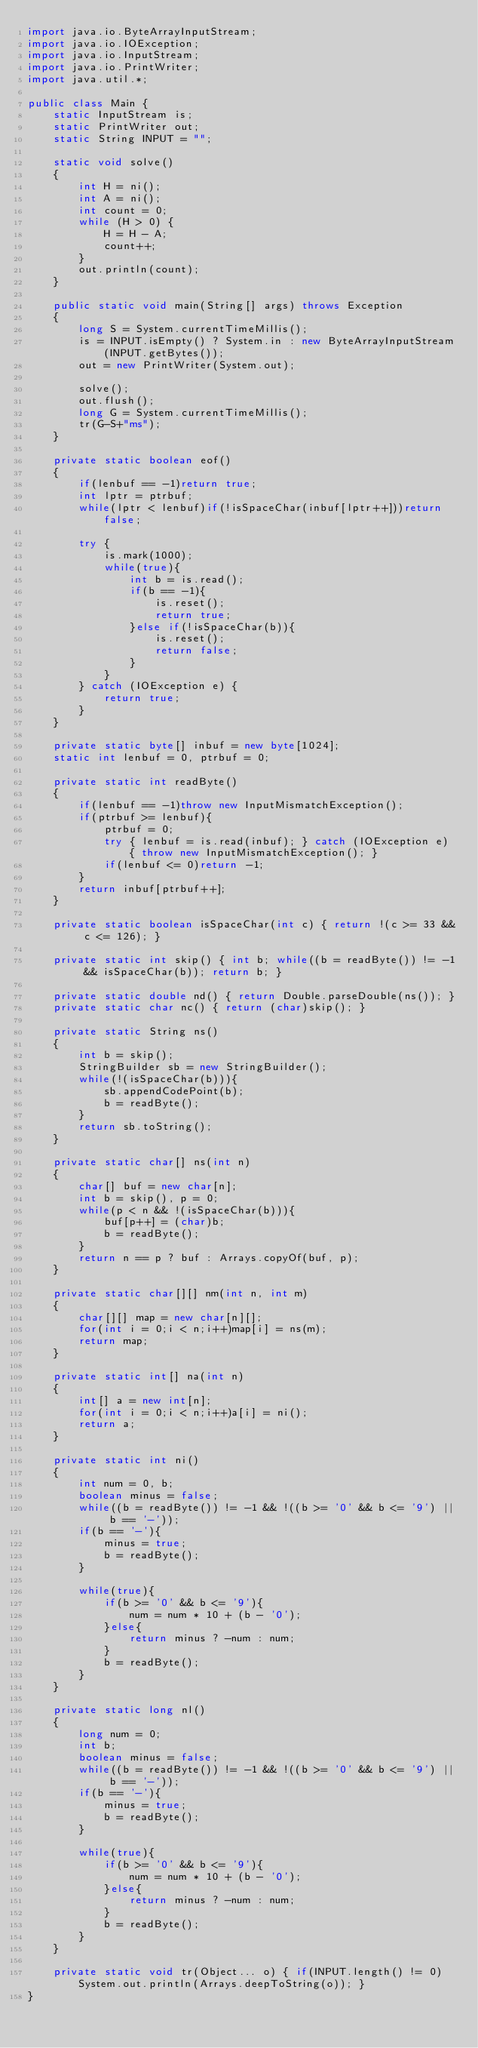Convert code to text. <code><loc_0><loc_0><loc_500><loc_500><_Java_>import java.io.ByteArrayInputStream;
import java.io.IOException;
import java.io.InputStream;
import java.io.PrintWriter;
import java.util.*;

public class Main {
    static InputStream is;
    static PrintWriter out;
    static String INPUT = "";

    static void solve()
    {
        int H = ni();
        int A = ni();
        int count = 0;
        while (H > 0) {
            H = H - A;
            count++;
        }
        out.println(count);
    }

    public static void main(String[] args) throws Exception
    {
        long S = System.currentTimeMillis();
        is = INPUT.isEmpty() ? System.in : new ByteArrayInputStream(INPUT.getBytes());
        out = new PrintWriter(System.out);

        solve();
        out.flush();
        long G = System.currentTimeMillis();
        tr(G-S+"ms");
    }

    private static boolean eof()
    {
        if(lenbuf == -1)return true;
        int lptr = ptrbuf;
        while(lptr < lenbuf)if(!isSpaceChar(inbuf[lptr++]))return false;

        try {
            is.mark(1000);
            while(true){
                int b = is.read();
                if(b == -1){
                    is.reset();
                    return true;
                }else if(!isSpaceChar(b)){
                    is.reset();
                    return false;
                }
            }
        } catch (IOException e) {
            return true;
        }
    }

    private static byte[] inbuf = new byte[1024];
    static int lenbuf = 0, ptrbuf = 0;

    private static int readByte()
    {
        if(lenbuf == -1)throw new InputMismatchException();
        if(ptrbuf >= lenbuf){
            ptrbuf = 0;
            try { lenbuf = is.read(inbuf); } catch (IOException e) { throw new InputMismatchException(); }
            if(lenbuf <= 0)return -1;
        }
        return inbuf[ptrbuf++];
    }

    private static boolean isSpaceChar(int c) { return !(c >= 33 && c <= 126); }

    private static int skip() { int b; while((b = readByte()) != -1 && isSpaceChar(b)); return b; }

    private static double nd() { return Double.parseDouble(ns()); }
    private static char nc() { return (char)skip(); }

    private static String ns()
    {
        int b = skip();
        StringBuilder sb = new StringBuilder();
        while(!(isSpaceChar(b))){
            sb.appendCodePoint(b);
            b = readByte();
        }
        return sb.toString();
    }

    private static char[] ns(int n)
    {
        char[] buf = new char[n];
        int b = skip(), p = 0;
        while(p < n && !(isSpaceChar(b))){
            buf[p++] = (char)b;
            b = readByte();
        }
        return n == p ? buf : Arrays.copyOf(buf, p);
    }

    private static char[][] nm(int n, int m)
    {
        char[][] map = new char[n][];
        for(int i = 0;i < n;i++)map[i] = ns(m);
        return map;
    }

    private static int[] na(int n)
    {
        int[] a = new int[n];
        for(int i = 0;i < n;i++)a[i] = ni();
        return a;
    }

    private static int ni()
    {
        int num = 0, b;
        boolean minus = false;
        while((b = readByte()) != -1 && !((b >= '0' && b <= '9') || b == '-'));
        if(b == '-'){
            minus = true;
            b = readByte();
        }

        while(true){
            if(b >= '0' && b <= '9'){
                num = num * 10 + (b - '0');
            }else{
                return minus ? -num : num;
            }
            b = readByte();
        }
    }

    private static long nl()
    {
        long num = 0;
        int b;
        boolean minus = false;
        while((b = readByte()) != -1 && !((b >= '0' && b <= '9') || b == '-'));
        if(b == '-'){
            minus = true;
            b = readByte();
        }

        while(true){
            if(b >= '0' && b <= '9'){
                num = num * 10 + (b - '0');
            }else{
                return minus ? -num : num;
            }
            b = readByte();
        }
    }

    private static void tr(Object... o) { if(INPUT.length() != 0)System.out.println(Arrays.deepToString(o)); }
}


</code> 